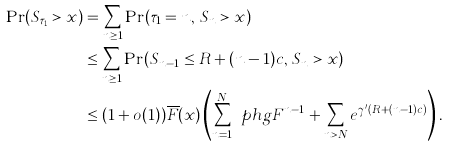Convert formula to latex. <formula><loc_0><loc_0><loc_500><loc_500>\Pr ( S _ { \tau _ { 1 } } > x ) & = \sum _ { n \geq 1 } \Pr ( \tau _ { 1 } = n , \, S _ { n } > x ) \\ & \leq \sum _ { n \geq 1 } \Pr ( S _ { n - 1 } \leq R + ( n - 1 ) c , \, S _ { n } > x ) \\ & \leq ( 1 + o ( 1 ) ) \overline { F } ( x ) \left ( \sum _ { n = 1 } ^ { N } \ p h g { F } ^ { n - 1 } + \sum _ { n > N } e ^ { \gamma ^ { \prime } ( R + ( n - 1 ) c ) } \right ) .</formula> 